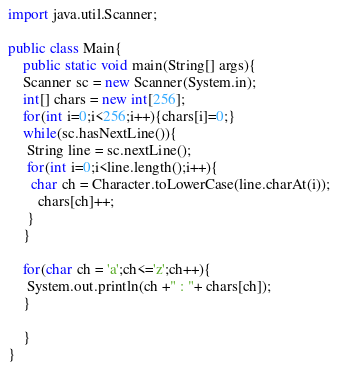Convert code to text. <code><loc_0><loc_0><loc_500><loc_500><_Java_>import java.util.Scanner;

public class Main{
	public static void main(String[] args){
	Scanner sc = new Scanner(System.in);
	int[] chars = new int[256];
	for(int i=0;i<256;i++){chars[i]=0;}
	while(sc.hasNextLine()){
	 String line = sc.nextLine();
	 for(int i=0;i<line.length();i++){
	  char ch = Character.toLowerCase(line.charAt(i));
		chars[ch]++;
	 }
	}
	
	for(char ch = 'a';ch<='z';ch++){
	 System.out.println(ch +" : "+ chars[ch]);
	}
	
	}
}</code> 